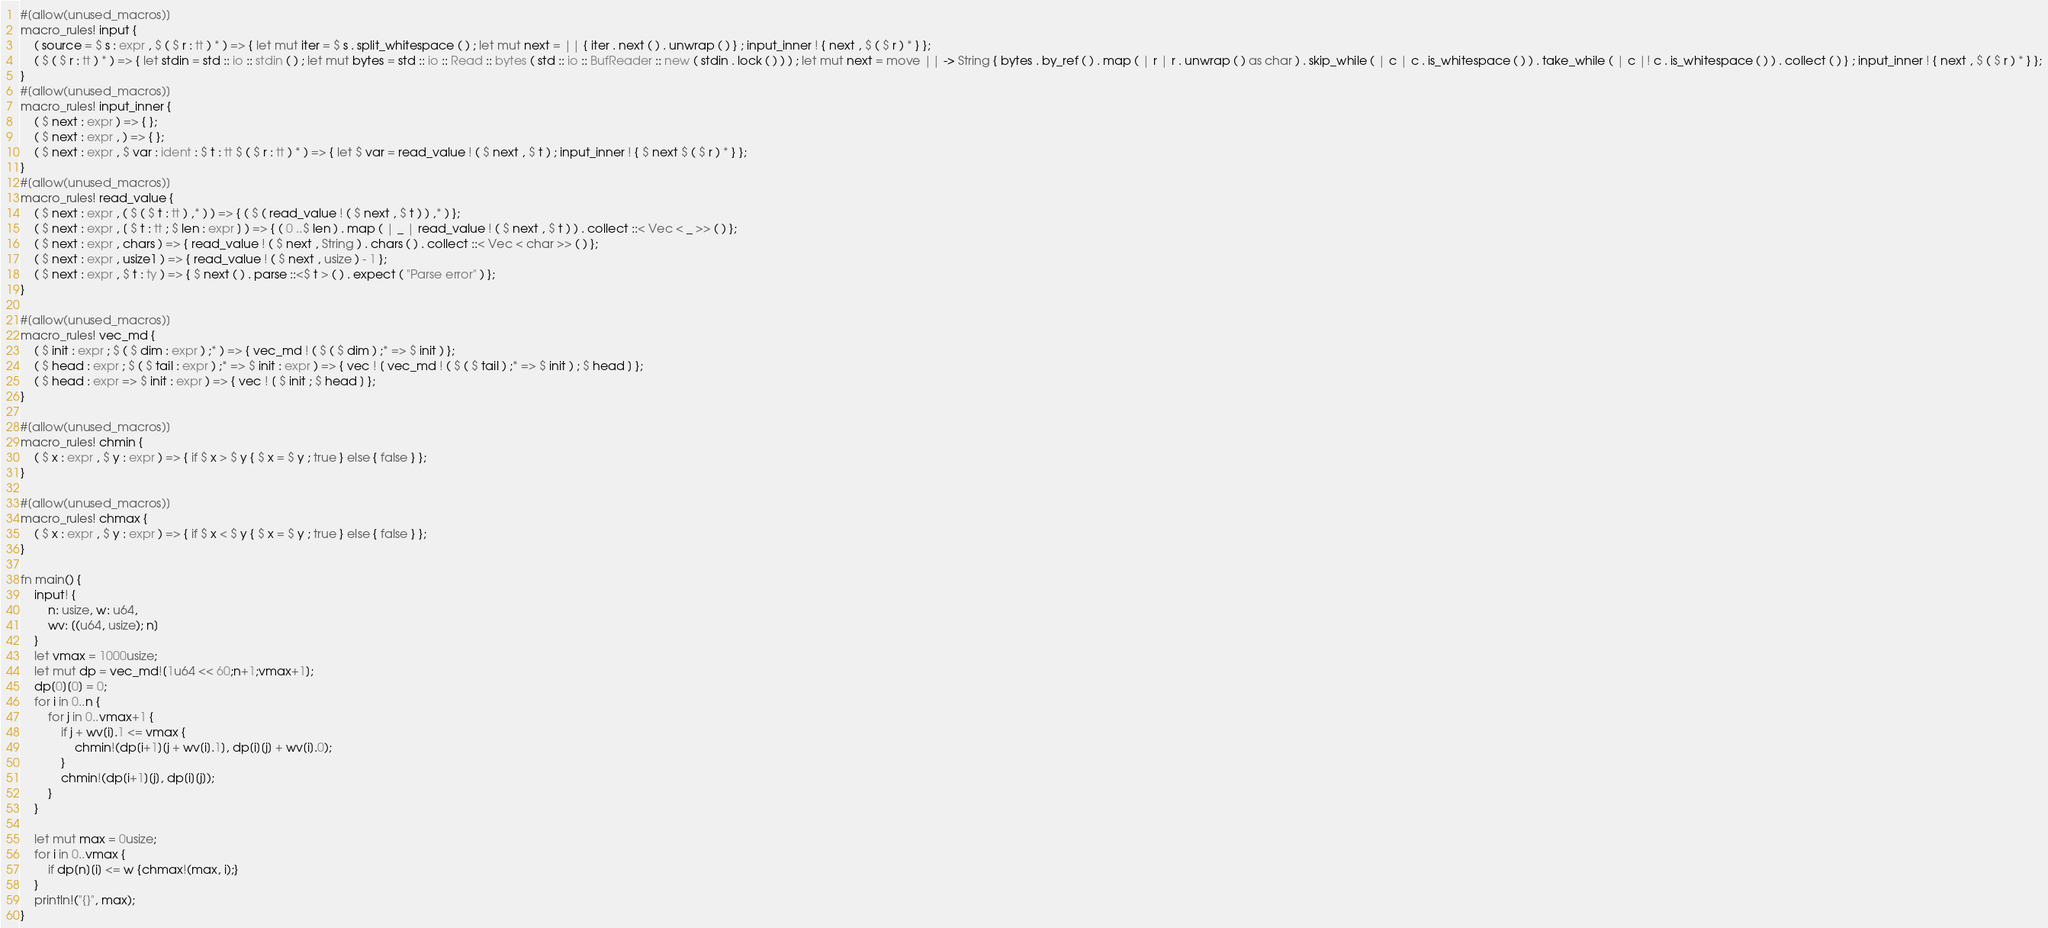<code> <loc_0><loc_0><loc_500><loc_500><_Rust_>#[allow(unused_macros)]
macro_rules! input {
    ( source = $ s : expr , $ ( $ r : tt ) * ) => { let mut iter = $ s . split_whitespace ( ) ; let mut next = || { iter . next ( ) . unwrap ( ) } ; input_inner ! { next , $ ( $ r ) * } };
    ( $ ( $ r : tt ) * ) => { let stdin = std :: io :: stdin ( ) ; let mut bytes = std :: io :: Read :: bytes ( std :: io :: BufReader :: new ( stdin . lock ( ) ) ) ; let mut next = move || -> String { bytes . by_ref ( ) . map ( | r | r . unwrap ( ) as char ) . skip_while ( | c | c . is_whitespace ( ) ) . take_while ( | c |! c . is_whitespace ( ) ) . collect ( ) } ; input_inner ! { next , $ ( $ r ) * } };
}
#[allow(unused_macros)]
macro_rules! input_inner {
    ( $ next : expr ) => { };
    ( $ next : expr , ) => { };
    ( $ next : expr , $ var : ident : $ t : tt $ ( $ r : tt ) * ) => { let $ var = read_value ! ( $ next , $ t ) ; input_inner ! { $ next $ ( $ r ) * } };
}
#[allow(unused_macros)]
macro_rules! read_value {
    ( $ next : expr , ( $ ( $ t : tt ) ,* ) ) => { ( $ ( read_value ! ( $ next , $ t ) ) ,* ) };
    ( $ next : expr , [ $ t : tt ; $ len : expr ] ) => { ( 0 ..$ len ) . map ( | _ | read_value ! ( $ next , $ t ) ) . collect ::< Vec < _ >> ( ) };
    ( $ next : expr , chars ) => { read_value ! ( $ next , String ) . chars ( ) . collect ::< Vec < char >> ( ) };
    ( $ next : expr , usize1 ) => { read_value ! ( $ next , usize ) - 1 };
    ( $ next : expr , $ t : ty ) => { $ next ( ) . parse ::<$ t > ( ) . expect ( "Parse error" ) };
}

#[allow(unused_macros)]
macro_rules! vec_md {
    ( $ init : expr ; $ ( $ dim : expr ) ;* ) => { vec_md ! ( $ ( $ dim ) ;* => $ init ) };
    ( $ head : expr ; $ ( $ tail : expr ) ;* => $ init : expr ) => { vec ! [ vec_md ! ( $ ( $ tail ) ;* => $ init ) ; $ head ] };
    ( $ head : expr => $ init : expr ) => { vec ! [ $ init ; $ head ] };
}

#[allow(unused_macros)]
macro_rules! chmin {
    ( $ x : expr , $ y : expr ) => { if $ x > $ y { $ x = $ y ; true } else { false } };
}

#[allow(unused_macros)]
macro_rules! chmax {
    ( $ x : expr , $ y : expr ) => { if $ x < $ y { $ x = $ y ; true } else { false } };
}

fn main() {
    input! {
        n: usize, w: u64,
        wv: [(u64, usize); n]
    }
    let vmax = 1000usize;
    let mut dp = vec_md![1u64 << 60;n+1;vmax+1];
    dp[0][0] = 0;
    for i in 0..n {
        for j in 0..vmax+1 {
            if j + wv[i].1 <= vmax {
                chmin!(dp[i+1][j + wv[i].1], dp[i][j] + wv[i].0);
            }
            chmin!(dp[i+1][j], dp[i][j]);
        }
    }

    let mut max = 0usize;
    for i in 0..vmax {
        if dp[n][i] <= w {chmax!(max, i);}
    }
    println!("{}", max);
}
</code> 